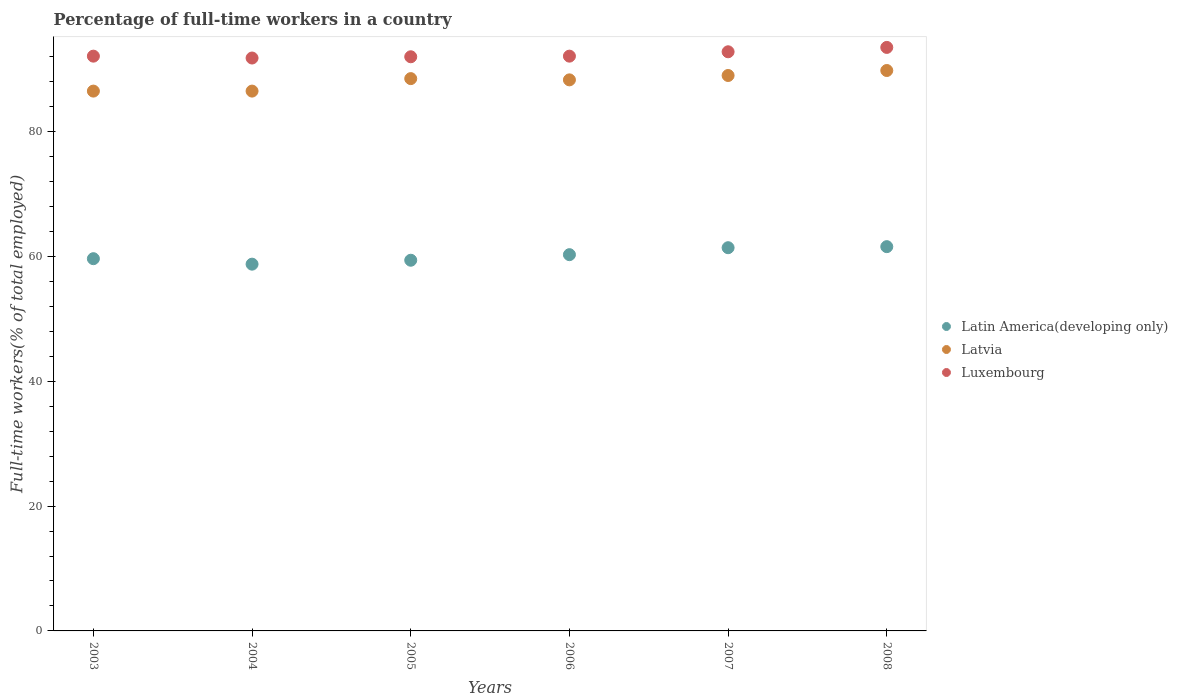How many different coloured dotlines are there?
Provide a succinct answer. 3. Is the number of dotlines equal to the number of legend labels?
Your response must be concise. Yes. What is the percentage of full-time workers in Latvia in 2004?
Give a very brief answer. 86.5. Across all years, what is the maximum percentage of full-time workers in Latin America(developing only)?
Your response must be concise. 61.57. Across all years, what is the minimum percentage of full-time workers in Luxembourg?
Provide a succinct answer. 91.8. What is the total percentage of full-time workers in Latin America(developing only) in the graph?
Your answer should be compact. 361.08. What is the difference between the percentage of full-time workers in Latvia in 2004 and that in 2007?
Make the answer very short. -2.5. What is the difference between the percentage of full-time workers in Latvia in 2003 and the percentage of full-time workers in Latin America(developing only) in 2005?
Your answer should be very brief. 27.1. What is the average percentage of full-time workers in Latin America(developing only) per year?
Provide a short and direct response. 60.18. In how many years, is the percentage of full-time workers in Latin America(developing only) greater than 72 %?
Offer a terse response. 0. What is the ratio of the percentage of full-time workers in Latvia in 2004 to that in 2007?
Make the answer very short. 0.97. Is the percentage of full-time workers in Latvia in 2004 less than that in 2007?
Make the answer very short. Yes. Is the difference between the percentage of full-time workers in Latvia in 2004 and 2008 greater than the difference between the percentage of full-time workers in Luxembourg in 2004 and 2008?
Make the answer very short. No. What is the difference between the highest and the second highest percentage of full-time workers in Latin America(developing only)?
Keep it short and to the point. 0.17. What is the difference between the highest and the lowest percentage of full-time workers in Luxembourg?
Make the answer very short. 1.7. In how many years, is the percentage of full-time workers in Latin America(developing only) greater than the average percentage of full-time workers in Latin America(developing only) taken over all years?
Offer a very short reply. 3. Is the sum of the percentage of full-time workers in Latin America(developing only) in 2005 and 2007 greater than the maximum percentage of full-time workers in Latvia across all years?
Offer a very short reply. Yes. Is the percentage of full-time workers in Luxembourg strictly greater than the percentage of full-time workers in Latvia over the years?
Your answer should be compact. Yes. Is the percentage of full-time workers in Luxembourg strictly less than the percentage of full-time workers in Latvia over the years?
Offer a terse response. No. What is the difference between two consecutive major ticks on the Y-axis?
Provide a short and direct response. 20. Are the values on the major ticks of Y-axis written in scientific E-notation?
Your answer should be very brief. No. Does the graph contain any zero values?
Provide a short and direct response. No. What is the title of the graph?
Ensure brevity in your answer.  Percentage of full-time workers in a country. What is the label or title of the Y-axis?
Keep it short and to the point. Full-time workers(% of total employed). What is the Full-time workers(% of total employed) in Latin America(developing only) in 2003?
Provide a short and direct response. 59.65. What is the Full-time workers(% of total employed) in Latvia in 2003?
Provide a short and direct response. 86.5. What is the Full-time workers(% of total employed) of Luxembourg in 2003?
Give a very brief answer. 92.1. What is the Full-time workers(% of total employed) of Latin America(developing only) in 2004?
Ensure brevity in your answer.  58.77. What is the Full-time workers(% of total employed) of Latvia in 2004?
Give a very brief answer. 86.5. What is the Full-time workers(% of total employed) in Luxembourg in 2004?
Keep it short and to the point. 91.8. What is the Full-time workers(% of total employed) in Latin America(developing only) in 2005?
Offer a terse response. 59.4. What is the Full-time workers(% of total employed) of Latvia in 2005?
Provide a succinct answer. 88.5. What is the Full-time workers(% of total employed) in Luxembourg in 2005?
Ensure brevity in your answer.  92. What is the Full-time workers(% of total employed) in Latin America(developing only) in 2006?
Make the answer very short. 60.29. What is the Full-time workers(% of total employed) of Latvia in 2006?
Provide a short and direct response. 88.3. What is the Full-time workers(% of total employed) in Luxembourg in 2006?
Keep it short and to the point. 92.1. What is the Full-time workers(% of total employed) of Latin America(developing only) in 2007?
Provide a short and direct response. 61.41. What is the Full-time workers(% of total employed) of Latvia in 2007?
Ensure brevity in your answer.  89. What is the Full-time workers(% of total employed) in Luxembourg in 2007?
Keep it short and to the point. 92.8. What is the Full-time workers(% of total employed) of Latin America(developing only) in 2008?
Provide a succinct answer. 61.57. What is the Full-time workers(% of total employed) of Latvia in 2008?
Offer a terse response. 89.8. What is the Full-time workers(% of total employed) of Luxembourg in 2008?
Give a very brief answer. 93.5. Across all years, what is the maximum Full-time workers(% of total employed) in Latin America(developing only)?
Ensure brevity in your answer.  61.57. Across all years, what is the maximum Full-time workers(% of total employed) of Latvia?
Make the answer very short. 89.8. Across all years, what is the maximum Full-time workers(% of total employed) of Luxembourg?
Offer a very short reply. 93.5. Across all years, what is the minimum Full-time workers(% of total employed) of Latin America(developing only)?
Offer a very short reply. 58.77. Across all years, what is the minimum Full-time workers(% of total employed) in Latvia?
Your answer should be compact. 86.5. Across all years, what is the minimum Full-time workers(% of total employed) of Luxembourg?
Provide a succinct answer. 91.8. What is the total Full-time workers(% of total employed) in Latin America(developing only) in the graph?
Provide a succinct answer. 361.08. What is the total Full-time workers(% of total employed) of Latvia in the graph?
Offer a terse response. 528.6. What is the total Full-time workers(% of total employed) in Luxembourg in the graph?
Offer a terse response. 554.3. What is the difference between the Full-time workers(% of total employed) in Latin America(developing only) in 2003 and that in 2004?
Offer a terse response. 0.88. What is the difference between the Full-time workers(% of total employed) of Latvia in 2003 and that in 2004?
Give a very brief answer. 0. What is the difference between the Full-time workers(% of total employed) in Luxembourg in 2003 and that in 2004?
Keep it short and to the point. 0.3. What is the difference between the Full-time workers(% of total employed) in Latin America(developing only) in 2003 and that in 2005?
Give a very brief answer. 0.25. What is the difference between the Full-time workers(% of total employed) of Luxembourg in 2003 and that in 2005?
Provide a short and direct response. 0.1. What is the difference between the Full-time workers(% of total employed) of Latin America(developing only) in 2003 and that in 2006?
Give a very brief answer. -0.64. What is the difference between the Full-time workers(% of total employed) in Luxembourg in 2003 and that in 2006?
Ensure brevity in your answer.  0. What is the difference between the Full-time workers(% of total employed) of Latin America(developing only) in 2003 and that in 2007?
Keep it short and to the point. -1.76. What is the difference between the Full-time workers(% of total employed) in Latvia in 2003 and that in 2007?
Ensure brevity in your answer.  -2.5. What is the difference between the Full-time workers(% of total employed) of Luxembourg in 2003 and that in 2007?
Make the answer very short. -0.7. What is the difference between the Full-time workers(% of total employed) in Latin America(developing only) in 2003 and that in 2008?
Provide a short and direct response. -1.93. What is the difference between the Full-time workers(% of total employed) in Latvia in 2003 and that in 2008?
Your answer should be compact. -3.3. What is the difference between the Full-time workers(% of total employed) of Latin America(developing only) in 2004 and that in 2005?
Provide a short and direct response. -0.63. What is the difference between the Full-time workers(% of total employed) of Latvia in 2004 and that in 2005?
Your answer should be compact. -2. What is the difference between the Full-time workers(% of total employed) of Latin America(developing only) in 2004 and that in 2006?
Ensure brevity in your answer.  -1.52. What is the difference between the Full-time workers(% of total employed) of Latvia in 2004 and that in 2006?
Offer a very short reply. -1.8. What is the difference between the Full-time workers(% of total employed) of Luxembourg in 2004 and that in 2006?
Provide a succinct answer. -0.3. What is the difference between the Full-time workers(% of total employed) of Latin America(developing only) in 2004 and that in 2007?
Your answer should be very brief. -2.64. What is the difference between the Full-time workers(% of total employed) of Latvia in 2004 and that in 2007?
Ensure brevity in your answer.  -2.5. What is the difference between the Full-time workers(% of total employed) of Luxembourg in 2004 and that in 2007?
Give a very brief answer. -1. What is the difference between the Full-time workers(% of total employed) in Latin America(developing only) in 2004 and that in 2008?
Make the answer very short. -2.81. What is the difference between the Full-time workers(% of total employed) of Luxembourg in 2004 and that in 2008?
Give a very brief answer. -1.7. What is the difference between the Full-time workers(% of total employed) in Latin America(developing only) in 2005 and that in 2006?
Keep it short and to the point. -0.89. What is the difference between the Full-time workers(% of total employed) of Latvia in 2005 and that in 2006?
Your answer should be compact. 0.2. What is the difference between the Full-time workers(% of total employed) in Latin America(developing only) in 2005 and that in 2007?
Your response must be concise. -2.01. What is the difference between the Full-time workers(% of total employed) in Luxembourg in 2005 and that in 2007?
Offer a very short reply. -0.8. What is the difference between the Full-time workers(% of total employed) of Latin America(developing only) in 2005 and that in 2008?
Your answer should be compact. -2.18. What is the difference between the Full-time workers(% of total employed) in Latvia in 2005 and that in 2008?
Keep it short and to the point. -1.3. What is the difference between the Full-time workers(% of total employed) in Latin America(developing only) in 2006 and that in 2007?
Offer a terse response. -1.12. What is the difference between the Full-time workers(% of total employed) of Latvia in 2006 and that in 2007?
Provide a succinct answer. -0.7. What is the difference between the Full-time workers(% of total employed) of Luxembourg in 2006 and that in 2007?
Ensure brevity in your answer.  -0.7. What is the difference between the Full-time workers(% of total employed) in Latin America(developing only) in 2006 and that in 2008?
Provide a succinct answer. -1.28. What is the difference between the Full-time workers(% of total employed) in Latvia in 2006 and that in 2008?
Your response must be concise. -1.5. What is the difference between the Full-time workers(% of total employed) in Latin America(developing only) in 2007 and that in 2008?
Offer a terse response. -0.17. What is the difference between the Full-time workers(% of total employed) of Latvia in 2007 and that in 2008?
Your answer should be very brief. -0.8. What is the difference between the Full-time workers(% of total employed) of Luxembourg in 2007 and that in 2008?
Provide a short and direct response. -0.7. What is the difference between the Full-time workers(% of total employed) of Latin America(developing only) in 2003 and the Full-time workers(% of total employed) of Latvia in 2004?
Provide a succinct answer. -26.85. What is the difference between the Full-time workers(% of total employed) of Latin America(developing only) in 2003 and the Full-time workers(% of total employed) of Luxembourg in 2004?
Offer a terse response. -32.15. What is the difference between the Full-time workers(% of total employed) of Latvia in 2003 and the Full-time workers(% of total employed) of Luxembourg in 2004?
Ensure brevity in your answer.  -5.3. What is the difference between the Full-time workers(% of total employed) in Latin America(developing only) in 2003 and the Full-time workers(% of total employed) in Latvia in 2005?
Offer a very short reply. -28.85. What is the difference between the Full-time workers(% of total employed) in Latin America(developing only) in 2003 and the Full-time workers(% of total employed) in Luxembourg in 2005?
Make the answer very short. -32.35. What is the difference between the Full-time workers(% of total employed) in Latin America(developing only) in 2003 and the Full-time workers(% of total employed) in Latvia in 2006?
Offer a terse response. -28.65. What is the difference between the Full-time workers(% of total employed) of Latin America(developing only) in 2003 and the Full-time workers(% of total employed) of Luxembourg in 2006?
Provide a short and direct response. -32.45. What is the difference between the Full-time workers(% of total employed) in Latin America(developing only) in 2003 and the Full-time workers(% of total employed) in Latvia in 2007?
Your answer should be compact. -29.35. What is the difference between the Full-time workers(% of total employed) of Latin America(developing only) in 2003 and the Full-time workers(% of total employed) of Luxembourg in 2007?
Your response must be concise. -33.15. What is the difference between the Full-time workers(% of total employed) in Latin America(developing only) in 2003 and the Full-time workers(% of total employed) in Latvia in 2008?
Ensure brevity in your answer.  -30.15. What is the difference between the Full-time workers(% of total employed) in Latin America(developing only) in 2003 and the Full-time workers(% of total employed) in Luxembourg in 2008?
Make the answer very short. -33.85. What is the difference between the Full-time workers(% of total employed) in Latin America(developing only) in 2004 and the Full-time workers(% of total employed) in Latvia in 2005?
Make the answer very short. -29.73. What is the difference between the Full-time workers(% of total employed) of Latin America(developing only) in 2004 and the Full-time workers(% of total employed) of Luxembourg in 2005?
Your answer should be very brief. -33.23. What is the difference between the Full-time workers(% of total employed) in Latvia in 2004 and the Full-time workers(% of total employed) in Luxembourg in 2005?
Offer a terse response. -5.5. What is the difference between the Full-time workers(% of total employed) in Latin America(developing only) in 2004 and the Full-time workers(% of total employed) in Latvia in 2006?
Keep it short and to the point. -29.53. What is the difference between the Full-time workers(% of total employed) in Latin America(developing only) in 2004 and the Full-time workers(% of total employed) in Luxembourg in 2006?
Provide a short and direct response. -33.33. What is the difference between the Full-time workers(% of total employed) of Latin America(developing only) in 2004 and the Full-time workers(% of total employed) of Latvia in 2007?
Offer a very short reply. -30.23. What is the difference between the Full-time workers(% of total employed) in Latin America(developing only) in 2004 and the Full-time workers(% of total employed) in Luxembourg in 2007?
Ensure brevity in your answer.  -34.03. What is the difference between the Full-time workers(% of total employed) of Latin America(developing only) in 2004 and the Full-time workers(% of total employed) of Latvia in 2008?
Ensure brevity in your answer.  -31.03. What is the difference between the Full-time workers(% of total employed) in Latin America(developing only) in 2004 and the Full-time workers(% of total employed) in Luxembourg in 2008?
Keep it short and to the point. -34.73. What is the difference between the Full-time workers(% of total employed) in Latvia in 2004 and the Full-time workers(% of total employed) in Luxembourg in 2008?
Make the answer very short. -7. What is the difference between the Full-time workers(% of total employed) of Latin America(developing only) in 2005 and the Full-time workers(% of total employed) of Latvia in 2006?
Your answer should be very brief. -28.9. What is the difference between the Full-time workers(% of total employed) in Latin America(developing only) in 2005 and the Full-time workers(% of total employed) in Luxembourg in 2006?
Provide a succinct answer. -32.7. What is the difference between the Full-time workers(% of total employed) of Latvia in 2005 and the Full-time workers(% of total employed) of Luxembourg in 2006?
Provide a short and direct response. -3.6. What is the difference between the Full-time workers(% of total employed) of Latin America(developing only) in 2005 and the Full-time workers(% of total employed) of Latvia in 2007?
Your response must be concise. -29.6. What is the difference between the Full-time workers(% of total employed) in Latin America(developing only) in 2005 and the Full-time workers(% of total employed) in Luxembourg in 2007?
Your response must be concise. -33.4. What is the difference between the Full-time workers(% of total employed) in Latvia in 2005 and the Full-time workers(% of total employed) in Luxembourg in 2007?
Provide a succinct answer. -4.3. What is the difference between the Full-time workers(% of total employed) of Latin America(developing only) in 2005 and the Full-time workers(% of total employed) of Latvia in 2008?
Keep it short and to the point. -30.4. What is the difference between the Full-time workers(% of total employed) of Latin America(developing only) in 2005 and the Full-time workers(% of total employed) of Luxembourg in 2008?
Keep it short and to the point. -34.1. What is the difference between the Full-time workers(% of total employed) in Latvia in 2005 and the Full-time workers(% of total employed) in Luxembourg in 2008?
Your response must be concise. -5. What is the difference between the Full-time workers(% of total employed) in Latin America(developing only) in 2006 and the Full-time workers(% of total employed) in Latvia in 2007?
Ensure brevity in your answer.  -28.71. What is the difference between the Full-time workers(% of total employed) in Latin America(developing only) in 2006 and the Full-time workers(% of total employed) in Luxembourg in 2007?
Offer a very short reply. -32.51. What is the difference between the Full-time workers(% of total employed) of Latin America(developing only) in 2006 and the Full-time workers(% of total employed) of Latvia in 2008?
Make the answer very short. -29.51. What is the difference between the Full-time workers(% of total employed) in Latin America(developing only) in 2006 and the Full-time workers(% of total employed) in Luxembourg in 2008?
Keep it short and to the point. -33.21. What is the difference between the Full-time workers(% of total employed) of Latvia in 2006 and the Full-time workers(% of total employed) of Luxembourg in 2008?
Give a very brief answer. -5.2. What is the difference between the Full-time workers(% of total employed) of Latin America(developing only) in 2007 and the Full-time workers(% of total employed) of Latvia in 2008?
Give a very brief answer. -28.39. What is the difference between the Full-time workers(% of total employed) in Latin America(developing only) in 2007 and the Full-time workers(% of total employed) in Luxembourg in 2008?
Offer a very short reply. -32.09. What is the average Full-time workers(% of total employed) in Latin America(developing only) per year?
Ensure brevity in your answer.  60.18. What is the average Full-time workers(% of total employed) in Latvia per year?
Offer a terse response. 88.1. What is the average Full-time workers(% of total employed) of Luxembourg per year?
Keep it short and to the point. 92.38. In the year 2003, what is the difference between the Full-time workers(% of total employed) of Latin America(developing only) and Full-time workers(% of total employed) of Latvia?
Your answer should be very brief. -26.85. In the year 2003, what is the difference between the Full-time workers(% of total employed) of Latin America(developing only) and Full-time workers(% of total employed) of Luxembourg?
Offer a very short reply. -32.45. In the year 2003, what is the difference between the Full-time workers(% of total employed) in Latvia and Full-time workers(% of total employed) in Luxembourg?
Ensure brevity in your answer.  -5.6. In the year 2004, what is the difference between the Full-time workers(% of total employed) of Latin America(developing only) and Full-time workers(% of total employed) of Latvia?
Keep it short and to the point. -27.73. In the year 2004, what is the difference between the Full-time workers(% of total employed) of Latin America(developing only) and Full-time workers(% of total employed) of Luxembourg?
Your answer should be compact. -33.03. In the year 2005, what is the difference between the Full-time workers(% of total employed) in Latin America(developing only) and Full-time workers(% of total employed) in Latvia?
Keep it short and to the point. -29.1. In the year 2005, what is the difference between the Full-time workers(% of total employed) in Latin America(developing only) and Full-time workers(% of total employed) in Luxembourg?
Provide a short and direct response. -32.6. In the year 2005, what is the difference between the Full-time workers(% of total employed) in Latvia and Full-time workers(% of total employed) in Luxembourg?
Your response must be concise. -3.5. In the year 2006, what is the difference between the Full-time workers(% of total employed) in Latin America(developing only) and Full-time workers(% of total employed) in Latvia?
Your response must be concise. -28.01. In the year 2006, what is the difference between the Full-time workers(% of total employed) in Latin America(developing only) and Full-time workers(% of total employed) in Luxembourg?
Provide a succinct answer. -31.81. In the year 2007, what is the difference between the Full-time workers(% of total employed) of Latin America(developing only) and Full-time workers(% of total employed) of Latvia?
Offer a very short reply. -27.59. In the year 2007, what is the difference between the Full-time workers(% of total employed) in Latin America(developing only) and Full-time workers(% of total employed) in Luxembourg?
Ensure brevity in your answer.  -31.39. In the year 2008, what is the difference between the Full-time workers(% of total employed) in Latin America(developing only) and Full-time workers(% of total employed) in Latvia?
Keep it short and to the point. -28.23. In the year 2008, what is the difference between the Full-time workers(% of total employed) of Latin America(developing only) and Full-time workers(% of total employed) of Luxembourg?
Keep it short and to the point. -31.93. In the year 2008, what is the difference between the Full-time workers(% of total employed) in Latvia and Full-time workers(% of total employed) in Luxembourg?
Make the answer very short. -3.7. What is the ratio of the Full-time workers(% of total employed) in Latin America(developing only) in 2003 to that in 2004?
Give a very brief answer. 1.01. What is the ratio of the Full-time workers(% of total employed) in Luxembourg in 2003 to that in 2004?
Ensure brevity in your answer.  1. What is the ratio of the Full-time workers(% of total employed) of Latvia in 2003 to that in 2005?
Your answer should be compact. 0.98. What is the ratio of the Full-time workers(% of total employed) in Luxembourg in 2003 to that in 2005?
Provide a succinct answer. 1. What is the ratio of the Full-time workers(% of total employed) of Latin America(developing only) in 2003 to that in 2006?
Offer a very short reply. 0.99. What is the ratio of the Full-time workers(% of total employed) of Latvia in 2003 to that in 2006?
Give a very brief answer. 0.98. What is the ratio of the Full-time workers(% of total employed) in Latin America(developing only) in 2003 to that in 2007?
Provide a short and direct response. 0.97. What is the ratio of the Full-time workers(% of total employed) in Latvia in 2003 to that in 2007?
Ensure brevity in your answer.  0.97. What is the ratio of the Full-time workers(% of total employed) of Luxembourg in 2003 to that in 2007?
Provide a succinct answer. 0.99. What is the ratio of the Full-time workers(% of total employed) in Latin America(developing only) in 2003 to that in 2008?
Ensure brevity in your answer.  0.97. What is the ratio of the Full-time workers(% of total employed) in Latvia in 2003 to that in 2008?
Make the answer very short. 0.96. What is the ratio of the Full-time workers(% of total employed) of Luxembourg in 2003 to that in 2008?
Offer a terse response. 0.98. What is the ratio of the Full-time workers(% of total employed) of Latin America(developing only) in 2004 to that in 2005?
Your answer should be compact. 0.99. What is the ratio of the Full-time workers(% of total employed) of Latvia in 2004 to that in 2005?
Make the answer very short. 0.98. What is the ratio of the Full-time workers(% of total employed) of Latin America(developing only) in 2004 to that in 2006?
Keep it short and to the point. 0.97. What is the ratio of the Full-time workers(% of total employed) in Latvia in 2004 to that in 2006?
Keep it short and to the point. 0.98. What is the ratio of the Full-time workers(% of total employed) of Luxembourg in 2004 to that in 2006?
Make the answer very short. 1. What is the ratio of the Full-time workers(% of total employed) of Latin America(developing only) in 2004 to that in 2007?
Give a very brief answer. 0.96. What is the ratio of the Full-time workers(% of total employed) of Latvia in 2004 to that in 2007?
Keep it short and to the point. 0.97. What is the ratio of the Full-time workers(% of total employed) of Latin America(developing only) in 2004 to that in 2008?
Keep it short and to the point. 0.95. What is the ratio of the Full-time workers(% of total employed) of Latvia in 2004 to that in 2008?
Your answer should be compact. 0.96. What is the ratio of the Full-time workers(% of total employed) of Luxembourg in 2004 to that in 2008?
Ensure brevity in your answer.  0.98. What is the ratio of the Full-time workers(% of total employed) in Latin America(developing only) in 2005 to that in 2006?
Your answer should be very brief. 0.99. What is the ratio of the Full-time workers(% of total employed) of Luxembourg in 2005 to that in 2006?
Make the answer very short. 1. What is the ratio of the Full-time workers(% of total employed) in Latin America(developing only) in 2005 to that in 2007?
Provide a succinct answer. 0.97. What is the ratio of the Full-time workers(% of total employed) of Latin America(developing only) in 2005 to that in 2008?
Provide a succinct answer. 0.96. What is the ratio of the Full-time workers(% of total employed) in Latvia in 2005 to that in 2008?
Keep it short and to the point. 0.99. What is the ratio of the Full-time workers(% of total employed) of Luxembourg in 2005 to that in 2008?
Offer a terse response. 0.98. What is the ratio of the Full-time workers(% of total employed) in Latin America(developing only) in 2006 to that in 2007?
Your answer should be compact. 0.98. What is the ratio of the Full-time workers(% of total employed) in Latin America(developing only) in 2006 to that in 2008?
Keep it short and to the point. 0.98. What is the ratio of the Full-time workers(% of total employed) of Latvia in 2006 to that in 2008?
Provide a succinct answer. 0.98. What is the ratio of the Full-time workers(% of total employed) of Luxembourg in 2006 to that in 2008?
Provide a short and direct response. 0.98. What is the difference between the highest and the second highest Full-time workers(% of total employed) in Latin America(developing only)?
Provide a short and direct response. 0.17. What is the difference between the highest and the second highest Full-time workers(% of total employed) of Latvia?
Keep it short and to the point. 0.8. What is the difference between the highest and the lowest Full-time workers(% of total employed) in Latin America(developing only)?
Provide a short and direct response. 2.81. What is the difference between the highest and the lowest Full-time workers(% of total employed) of Luxembourg?
Provide a succinct answer. 1.7. 